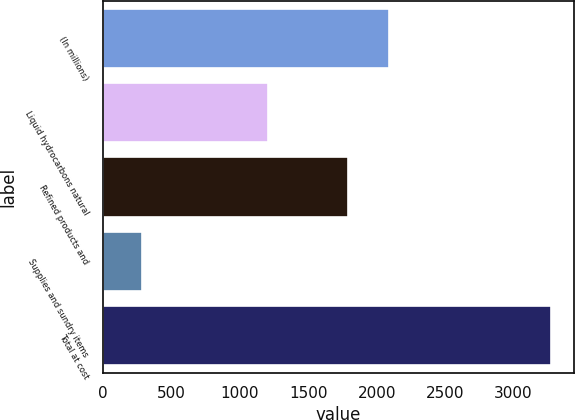<chart> <loc_0><loc_0><loc_500><loc_500><bar_chart><fcel>(In millions)<fcel>Liquid hydrocarbons natural<fcel>Refined products and<fcel>Supplies and sundry items<fcel>Total at cost<nl><fcel>2091.5<fcel>1203<fcel>1792<fcel>282<fcel>3277<nl></chart> 